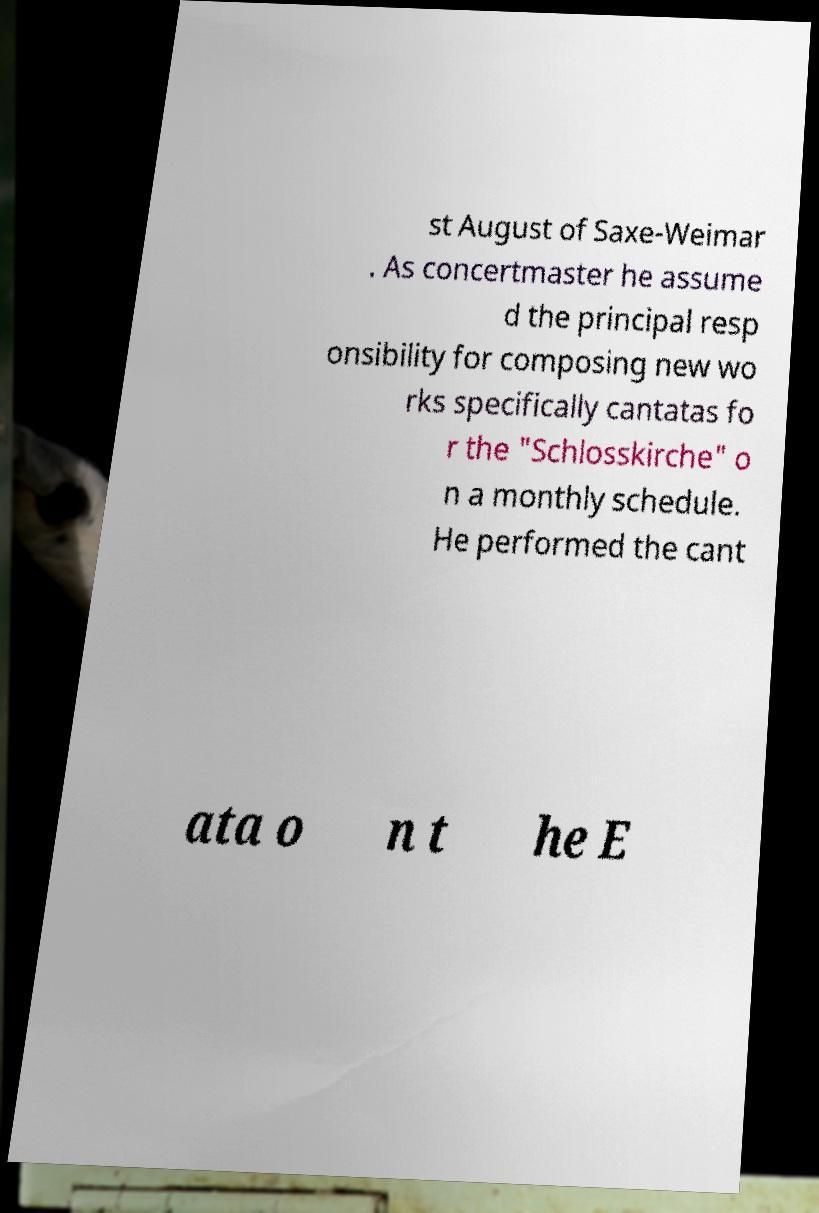I need the written content from this picture converted into text. Can you do that? st August of Saxe-Weimar . As concertmaster he assume d the principal resp onsibility for composing new wo rks specifically cantatas fo r the "Schlosskirche" o n a monthly schedule. He performed the cant ata o n t he E 